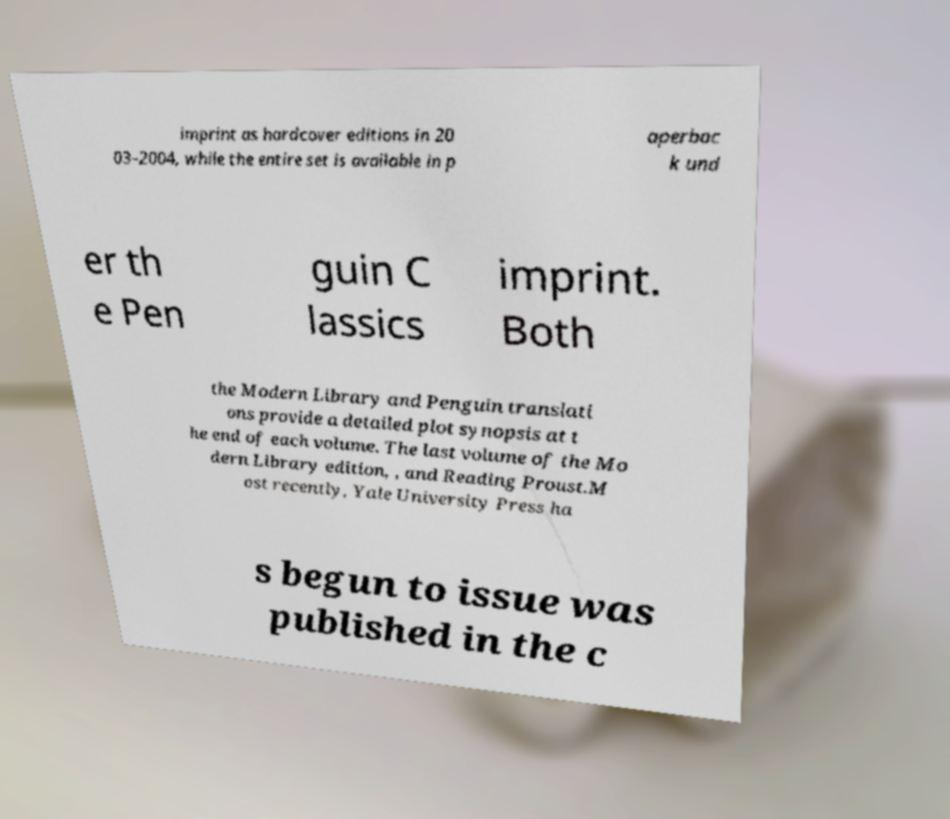I need the written content from this picture converted into text. Can you do that? imprint as hardcover editions in 20 03–2004, while the entire set is available in p aperbac k und er th e Pen guin C lassics imprint. Both the Modern Library and Penguin translati ons provide a detailed plot synopsis at t he end of each volume. The last volume of the Mo dern Library edition, , and Reading Proust.M ost recently, Yale University Press ha s begun to issue was published in the c 